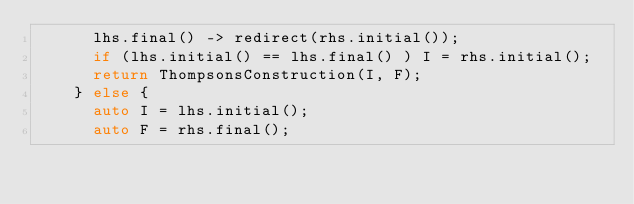Convert code to text. <code><loc_0><loc_0><loc_500><loc_500><_C++_>      lhs.final() -> redirect(rhs.initial());
      if (lhs.initial() == lhs.final() ) I = rhs.initial();
      return ThompsonsConstruction(I, F);
    } else {
      auto I = lhs.initial();
      auto F = rhs.final();</code> 